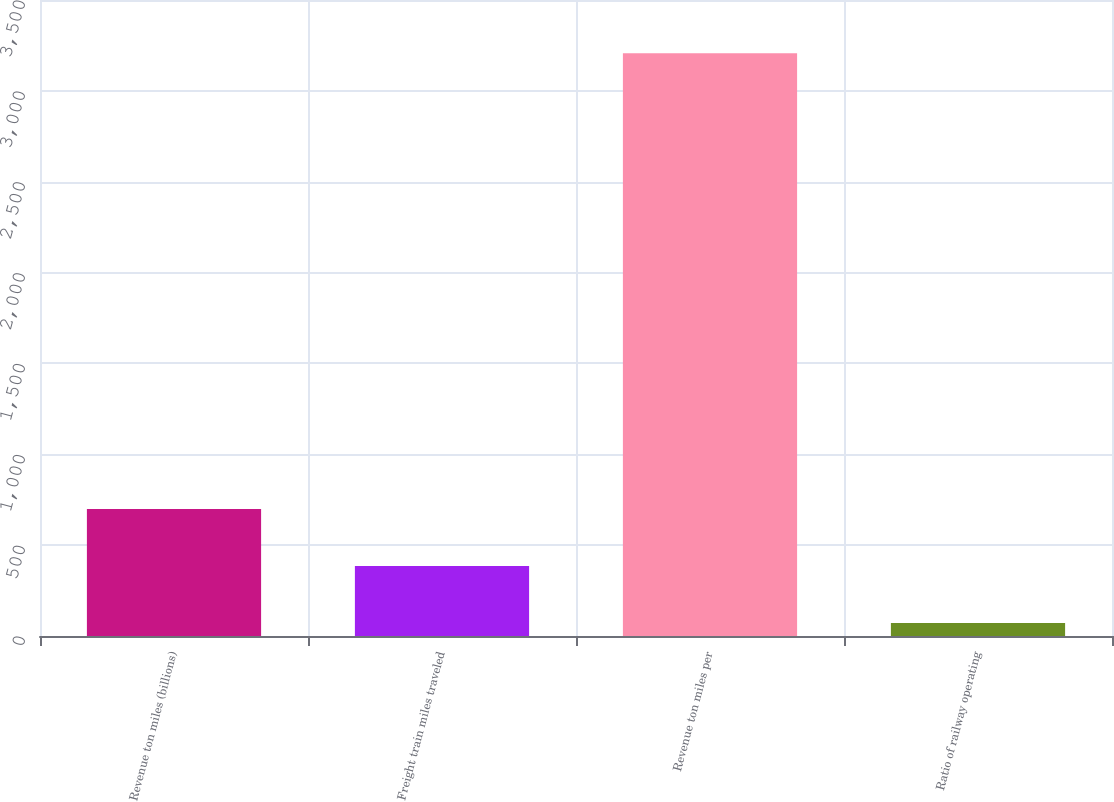Convert chart. <chart><loc_0><loc_0><loc_500><loc_500><bar_chart><fcel>Revenue ton miles (billions)<fcel>Freight train miles traveled<fcel>Revenue ton miles per<fcel>Ratio of railway operating<nl><fcel>698.36<fcel>384.78<fcel>3207<fcel>71.2<nl></chart> 